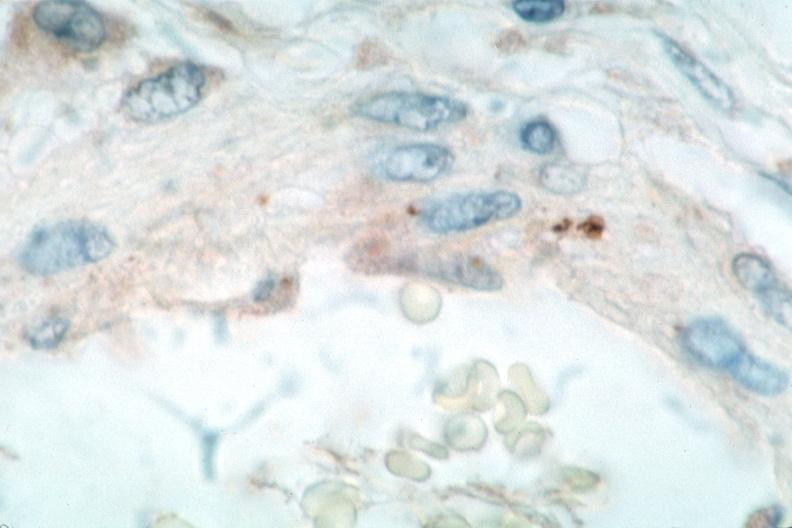s papillary intraductal adenocarcinoma spotted fever, immunoperoxidase staining vessels for rickettsia rickettsii?
Answer the question using a single word or phrase. No 